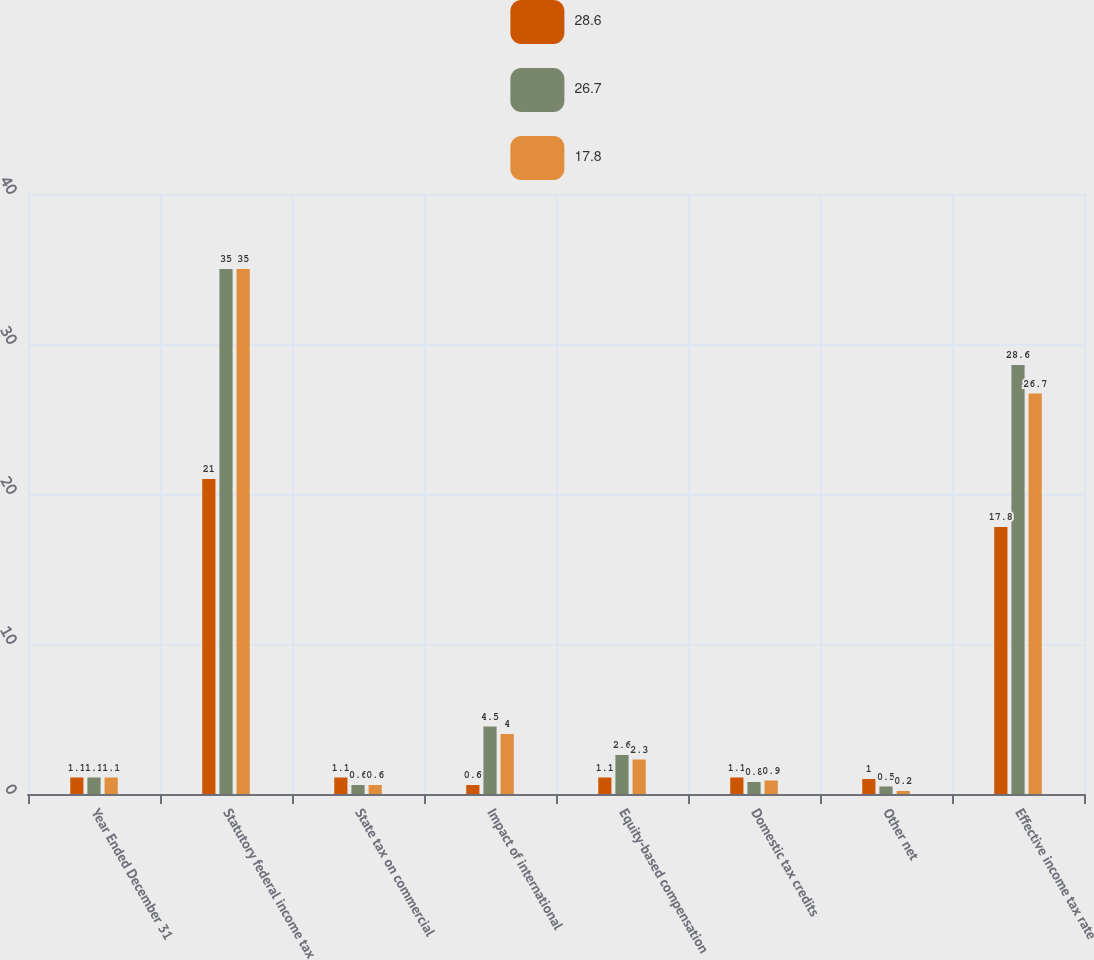Convert chart. <chart><loc_0><loc_0><loc_500><loc_500><stacked_bar_chart><ecel><fcel>Year Ended December 31<fcel>Statutory federal income tax<fcel>State tax on commercial<fcel>Impact of international<fcel>Equity-based compensation<fcel>Domestic tax credits<fcel>Other net<fcel>Effective income tax rate<nl><fcel>28.6<fcel>1.1<fcel>21<fcel>1.1<fcel>0.6<fcel>1.1<fcel>1.1<fcel>1<fcel>17.8<nl><fcel>26.7<fcel>1.1<fcel>35<fcel>0.6<fcel>4.5<fcel>2.6<fcel>0.8<fcel>0.5<fcel>28.6<nl><fcel>17.8<fcel>1.1<fcel>35<fcel>0.6<fcel>4<fcel>2.3<fcel>0.9<fcel>0.2<fcel>26.7<nl></chart> 